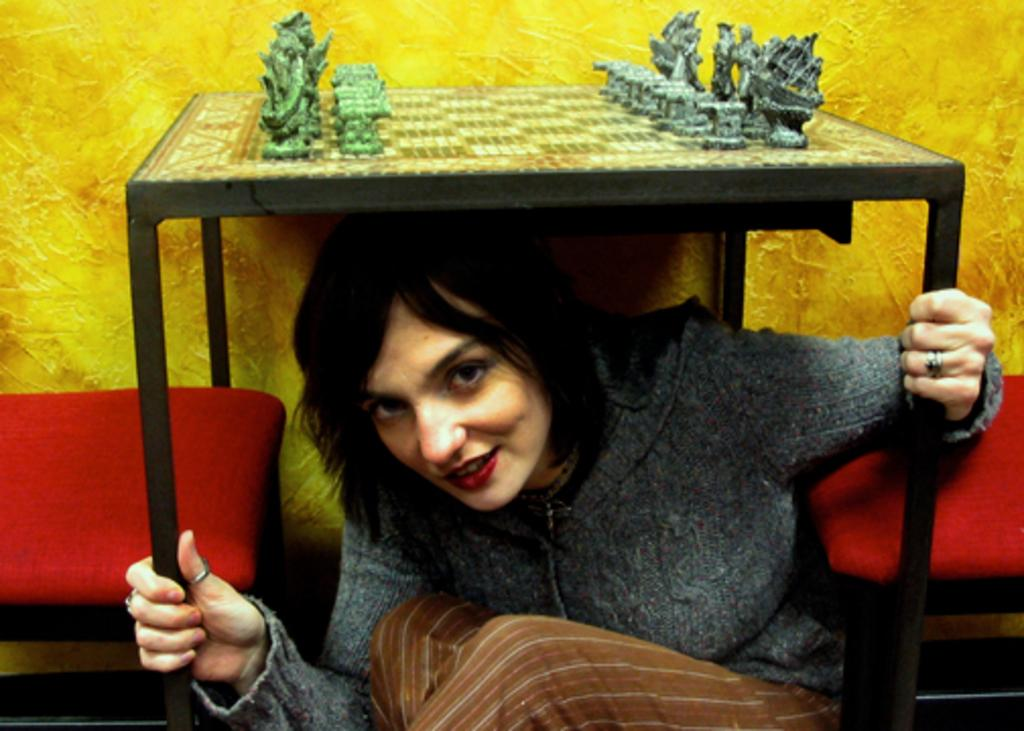Who is present in the image? There is a woman in the image. What is the woman wearing? The woman is wearing a grey top. Where is the woman located in the image? The woman is sitting under a table. What can be seen on the table? There are idols on the table. What type of furniture is present in the image? There is a chair in the image. What type of meat is being sold in the store in the image? There is no store or meat present in the image. Can you tell me how many monkeys are sitting on the chair in the image? There are no monkeys present in the image. 